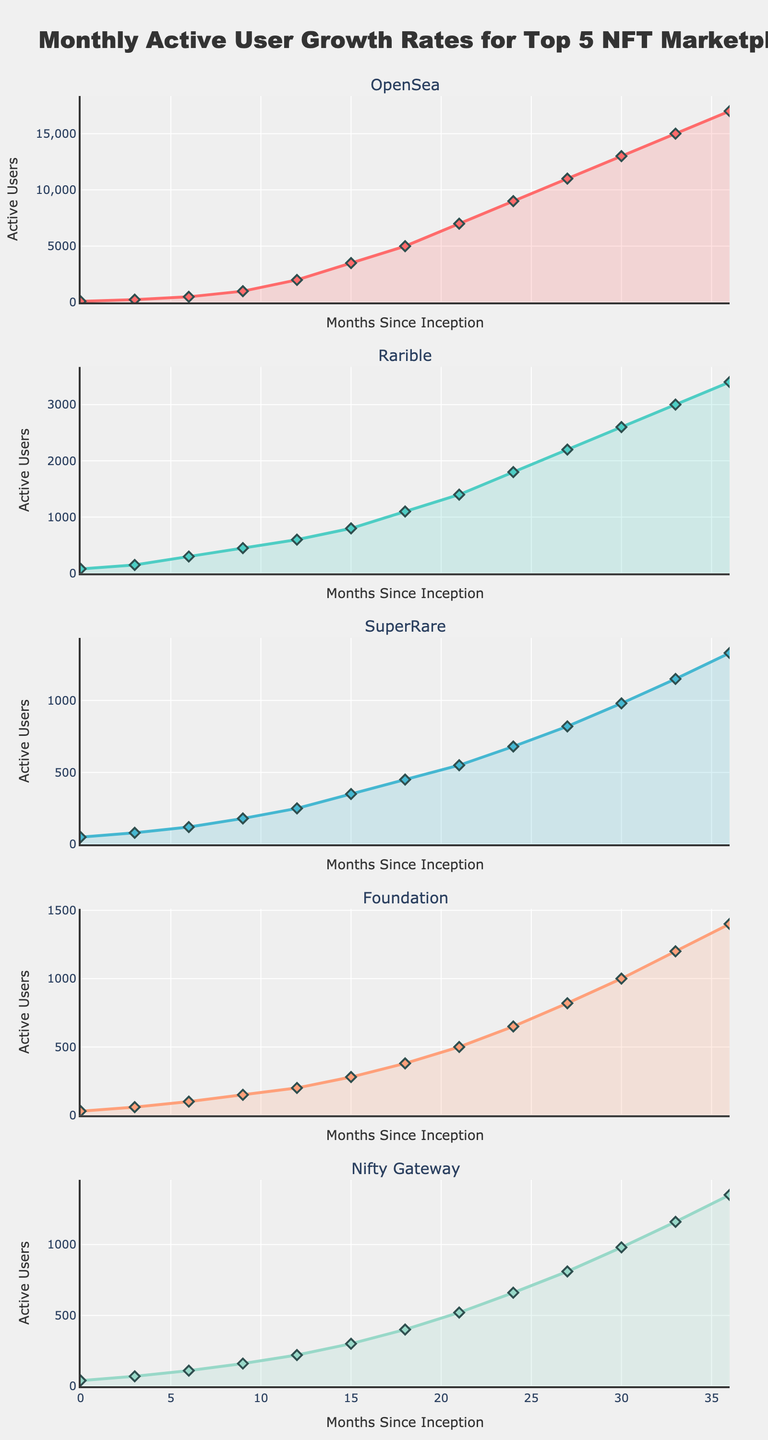What is the title of the figure? The title of the figure is located at the top of the plot and summarizes the main topic depicted.
Answer: Monthly Active User Growth Rates for Top 5 NFT Marketplaces How many rows of subplots are there? The rows of subplots can be counted vertically from top to bottom.
Answer: 5 What does the x-axis represent? The x-axis spans from left to right at the bottom of each subplot and typically contains the labels for months since inception.
Answer: Months Since Inception What is the y-axis title? The y-axis title is placed vertically along the left side of each subplot and signifies what is being measured.
Answer: Active Users Which NFT marketplace has the highest number of active users in the final month? Identify the highest point in the subplot corresponding to the final month (36) and observe which curve it belongs to.
Answer: OpenSea During which months did SuperRare see rapid increases in active users? Evaluate the slope of the SuperRare plot, noting months where the slope is steepest, indicating rapid growth.
Answer: Months 18-21 and 30-36 Compare the active users for Foundation and Nifty Gateway at month 27. Which one is higher? Locate month 27 on the x-axis and compare the corresponding points on the Foundation and Nifty Gateway plots.
Answer: Nifty Gateway What is the overall trend in Rarible's active users from month 0 to month 36? Observe the progression of the Rarible plot from start to end, noting whether it consistently increases, decreases, or fluctuates.
Answer: Increasing How much higher is OpenSea’s active user count than SuperRare’s at month 12? Check the active user vertical positions for OpenSea and SuperRare at month 12 and calculate the difference.
Answer: 1750 users By how many users did OpenSea’s active users increase from month 30 to month 36? Identify and subtract the active user counts of OpenSea at months 30 and 36.
Answer: 4000 users 